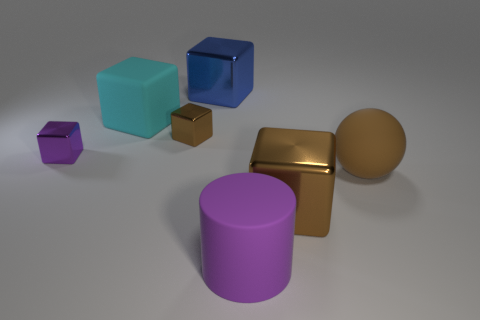There is a cyan cube that is the same material as the sphere; what size is it?
Your answer should be very brief. Large. There is a shiny thing right of the blue object; is it the same shape as the cyan rubber thing?
Keep it short and to the point. Yes. What number of cyan objects are either big cubes or large cylinders?
Provide a short and direct response. 1. How many other objects are there of the same shape as the cyan object?
Offer a terse response. 4. What shape is the object that is behind the big purple matte thing and in front of the big ball?
Keep it short and to the point. Cube. Are there any metallic cubes left of the big purple cylinder?
Offer a very short reply. Yes. There is a matte thing that is the same shape as the tiny brown metallic thing; what size is it?
Provide a short and direct response. Large. Do the purple metallic thing and the big blue shiny object have the same shape?
Offer a terse response. Yes. There is a brown block behind the small shiny thing in front of the tiny brown metal thing; how big is it?
Offer a terse response. Small. What color is the other tiny shiny object that is the same shape as the tiny brown object?
Your answer should be compact. Purple. 